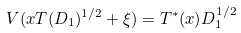Convert formula to latex. <formula><loc_0><loc_0><loc_500><loc_500>V ( x T ( D _ { 1 } ) ^ { 1 / 2 } + \xi ) = T ^ { * } ( x ) D _ { 1 } ^ { 1 / 2 }</formula> 